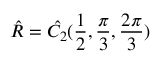<formula> <loc_0><loc_0><loc_500><loc_500>\hat { R } = \hat { C _ { 2 } } ( \frac { 1 } { 2 } , \frac { \pi } { 3 } , \frac { 2 \pi } { 3 } )</formula> 